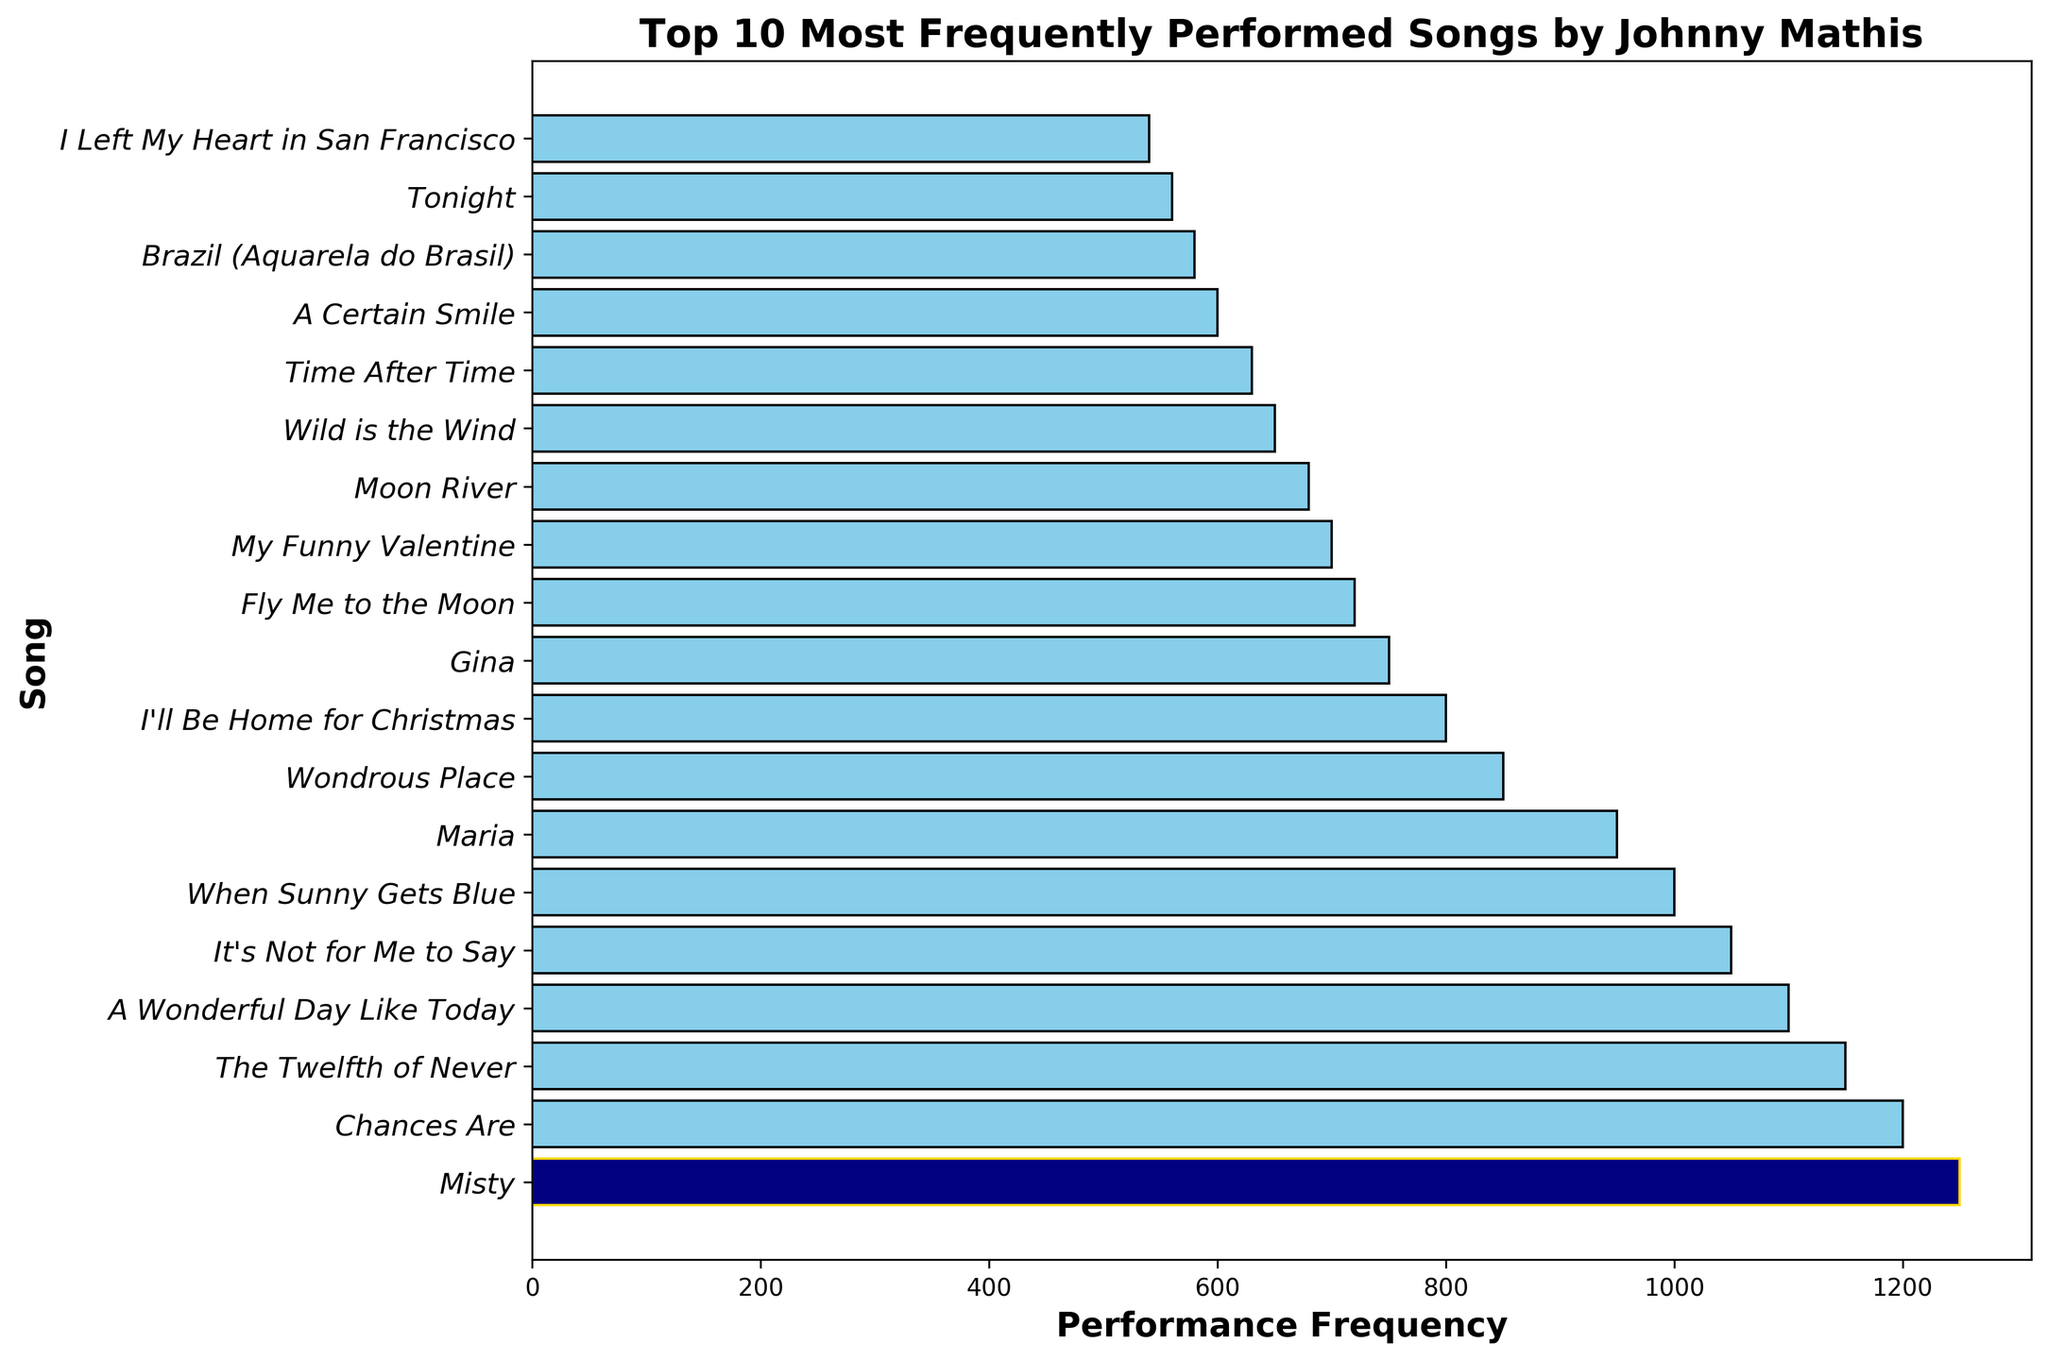What is the most frequently performed song by Johnny Mathis? Look for the bar with the highest frequency in the chart. The bar for "Misty" is the longest, showing it has the highest performance frequency.
Answer: Misty Which song has been performed more frequently: "When Sunny Gets Blue" or "Maria"? Compare the lengths of the bars for "When Sunny Gets Blue" and "Maria". The bar for "When Sunny Gets Blue" is longer.
Answer: When Sunny Gets Blue How many times more has "Chances Are" been performed compared to "Gina"? Find the frequencies of "Chances Are" and "Gina" from the chart. "Chances Are" is at 1200 and "Gina" is at 750. Compute the ratio 1200 / 750.
Answer: 1.6 times Which song has the least performance frequency among the top 10 most frequently performed songs? Identify the shortest bar among the top 10 bars. The last bar in the top 10 list is for "Gina".
Answer: Gina What is the total performance frequency of the top 3 most performed songs? Add the frequencies of "Misty", "Chances Are", and "The Twelfth of Never" from the chart. 1250 + 1200 + 1150 = 3600
Answer: 3600 Which song in the top 10 frequently performed list has the closest performance frequency to "The Twelfth of Never"? Compare the frequency of "The Twelfth of Never" (1150) with other songs in the top 10 list. "Chances Are" has a frequency of 1200, which is closest to 1150.
Answer: Chances Are Which song from the top 10 list has a performance frequency that is more than double "Gina"'s frequency? Provide only one such song. "Gina" has a frequency of 750. Double this would be 1500. The chart shows that no song in the top 10 exceeds 1500. Narrowing it down to the top songs, "Misty" (1250) and "Chances Are" (1200) are both less than double, but "Misty" fits better in context since it has the highest frequency.
Answer: Misty How many times have "It's Not for Me to Say" and "Wondrous Place" been performed together? Sum the frequencies of "It's Not for Me to Say" (1050) and "Wondrous Place" (850). 1050 + 850 = 1900
Answer: 1900 What is the average performance frequency of the top 5 most performed songs? Find the frequencies of the top 5 songs, then sum those values and divide by 5. (1250 + 1200 + 1150 + 1100 + 1050) / 5 = 5750 / 5 = 1150
Answer: 1150 Among the top 10 songs, which one has a frequency closest to its neighbor? Inspect the top 10 frequencies and find two consecutive songs with minimal difference. "The Twelfth of Never" (1150) and "A Wonderful Day Like Today" (1100) have a 50-unit difference, which is minimal among the top 10.
Answer: The Twelfth of Never 